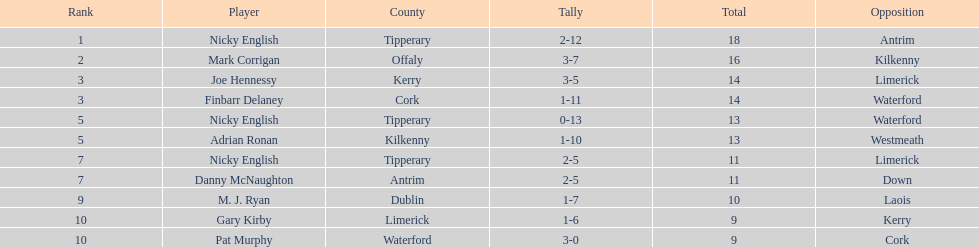If you summed all the totals, what would the figure be? 138. 